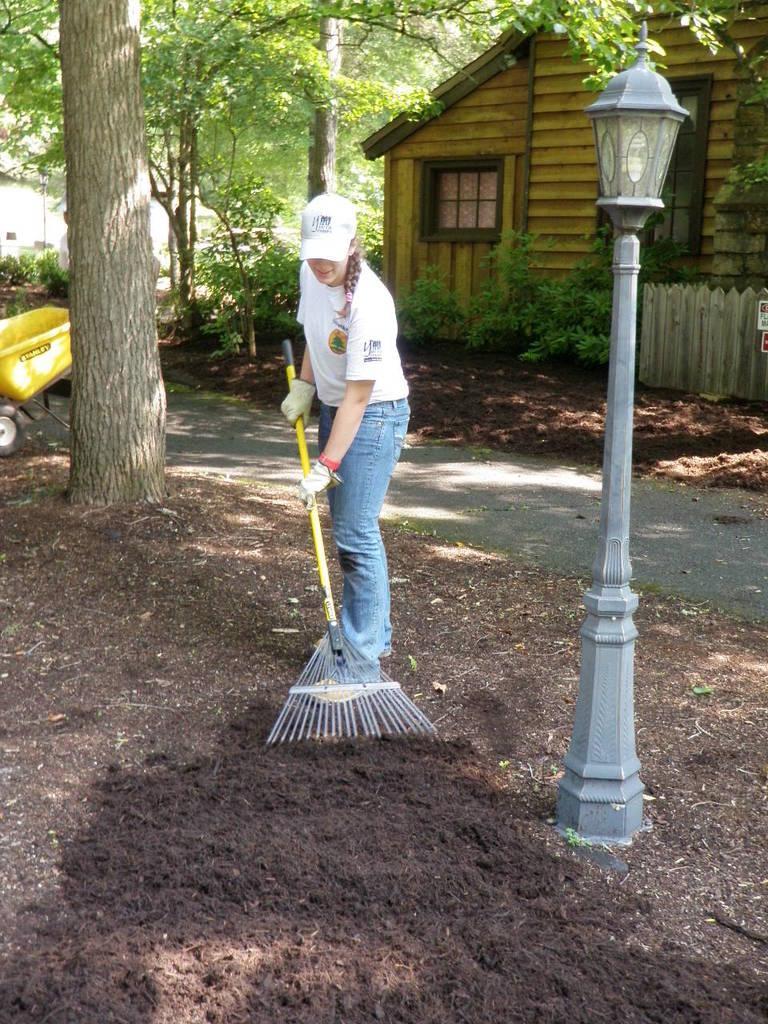Can you describe this image briefly? In this image I can see a person wearing white shirt, blue pant and holding a stick. I can also see a light pole, background I can see a house in brown color, trees in green color. 